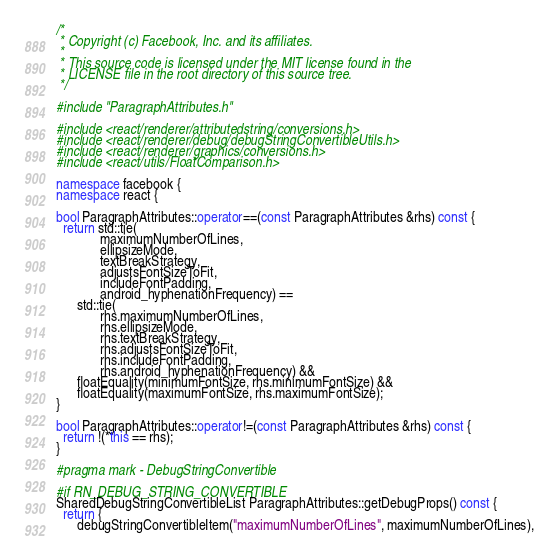Convert code to text. <code><loc_0><loc_0><loc_500><loc_500><_C++_>/*
 * Copyright (c) Facebook, Inc. and its affiliates.
 *
 * This source code is licensed under the MIT license found in the
 * LICENSE file in the root directory of this source tree.
 */

#include "ParagraphAttributes.h"

#include <react/renderer/attributedstring/conversions.h>
#include <react/renderer/debug/debugStringConvertibleUtils.h>
#include <react/renderer/graphics/conversions.h>
#include <react/utils/FloatComparison.h>

namespace facebook {
namespace react {

bool ParagraphAttributes::operator==(const ParagraphAttributes &rhs) const {
  return std::tie(
             maximumNumberOfLines,
             ellipsizeMode,
             textBreakStrategy,
             adjustsFontSizeToFit,
             includeFontPadding,
             android_hyphenationFrequency) ==
      std::tie(
             rhs.maximumNumberOfLines,
             rhs.ellipsizeMode,
             rhs.textBreakStrategy,
             rhs.adjustsFontSizeToFit,
             rhs.includeFontPadding,
             rhs.android_hyphenationFrequency) &&
      floatEquality(minimumFontSize, rhs.minimumFontSize) &&
      floatEquality(maximumFontSize, rhs.maximumFontSize);
}

bool ParagraphAttributes::operator!=(const ParagraphAttributes &rhs) const {
  return !(*this == rhs);
}

#pragma mark - DebugStringConvertible

#if RN_DEBUG_STRING_CONVERTIBLE
SharedDebugStringConvertibleList ParagraphAttributes::getDebugProps() const {
  return {
      debugStringConvertibleItem("maximumNumberOfLines", maximumNumberOfLines),</code> 